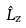Convert formula to latex. <formula><loc_0><loc_0><loc_500><loc_500>\hat { L } _ { z }</formula> 